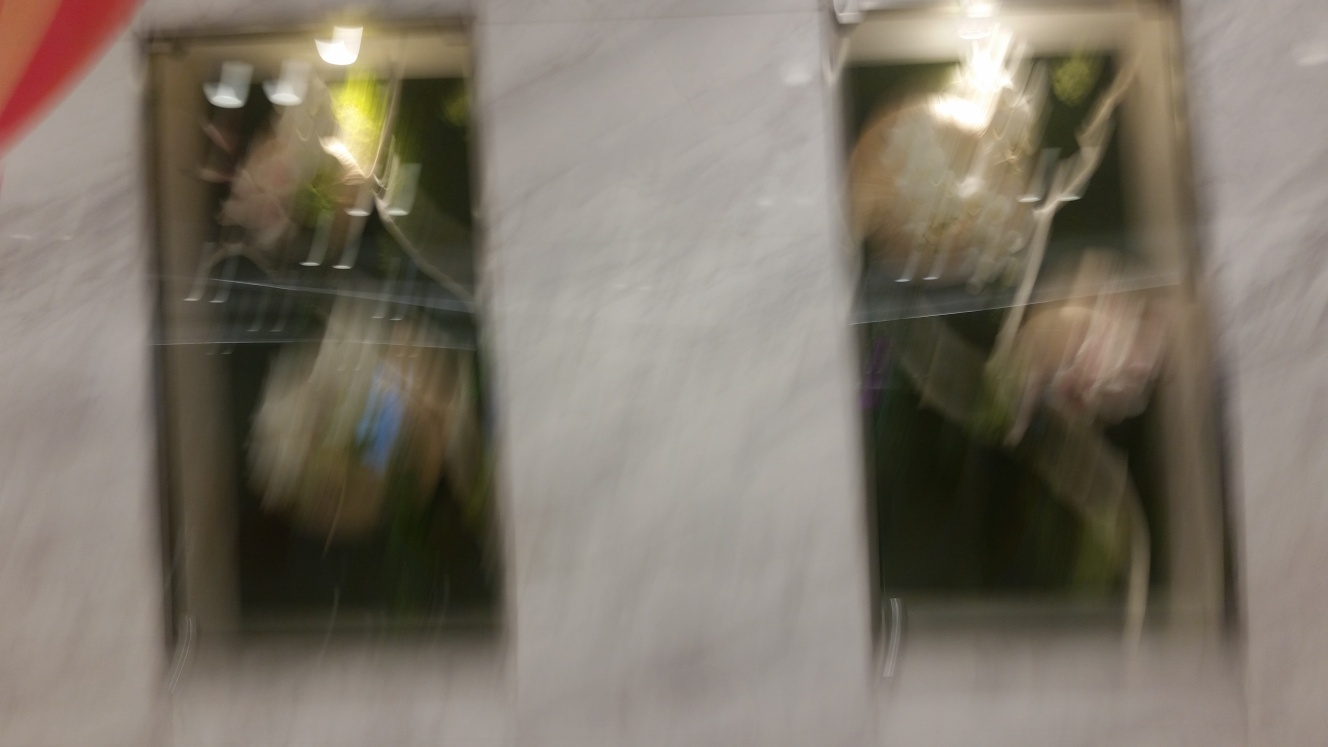Is the photo completely level? Based on the visible lines and the overall composition, the photo does not appear to be completely level. In this case, the blur may suggest motion or a sudden shift while taking the photo, which could also affect the perceived alignment. It's recommended to use a grid or level tool when capturing images to ensure they are even. 